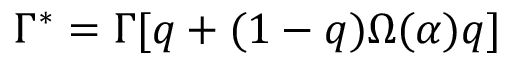<formula> <loc_0><loc_0><loc_500><loc_500>\Gamma ^ { * } = \Gamma [ q + ( 1 - q ) \Omega ( \alpha ) q ]</formula> 